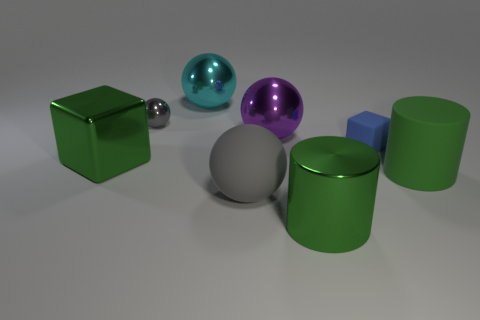Subtract all gray rubber balls. How many balls are left? 3 Subtract all cyan spheres. How many spheres are left? 3 Add 1 gray matte balls. How many objects exist? 9 Subtract all blue cylinders. How many gray spheres are left? 2 Subtract 1 balls. How many balls are left? 3 Subtract all cyan balls. Subtract all purple cubes. How many balls are left? 3 Add 5 small gray shiny objects. How many small gray shiny objects exist? 6 Subtract 0 purple cylinders. How many objects are left? 8 Subtract all blocks. How many objects are left? 6 Subtract all purple shiny objects. Subtract all blocks. How many objects are left? 5 